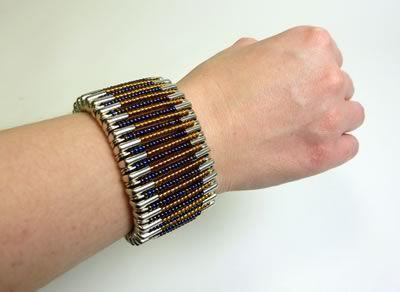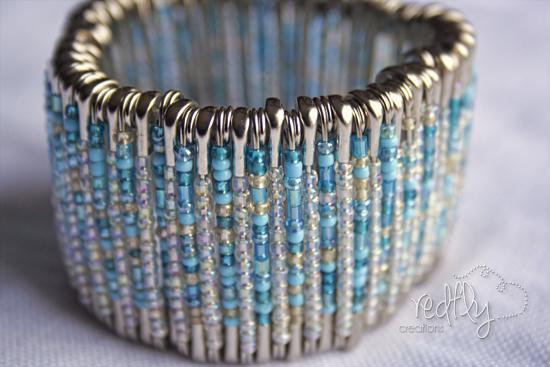The first image is the image on the left, the second image is the image on the right. Assess this claim about the two images: "there is an arm in the image on the right.". Correct or not? Answer yes or no. No. The first image is the image on the left, the second image is the image on the right. Evaluate the accuracy of this statement regarding the images: "In the right image, the bracelet is shown on a wrist.". Is it true? Answer yes or no. No. 